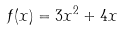<formula> <loc_0><loc_0><loc_500><loc_500>f ( x ) = 3 x ^ { 2 } + 4 x</formula> 